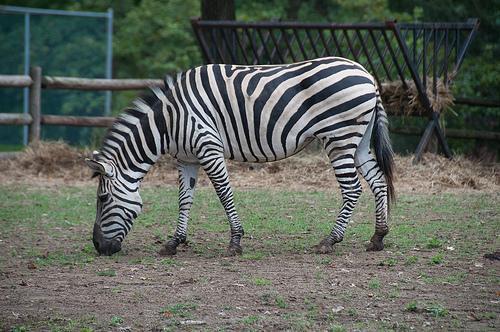How many zebra are pictured?
Give a very brief answer. 1. How many legs does the zebra have?
Give a very brief answer. 4. 